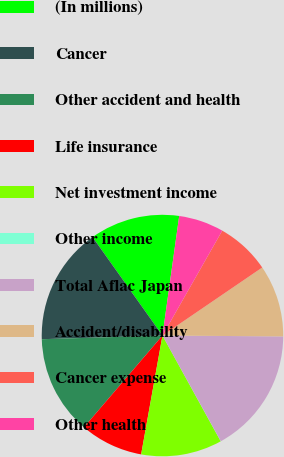Convert chart to OTSL. <chart><loc_0><loc_0><loc_500><loc_500><pie_chart><fcel>(In millions)<fcel>Cancer<fcel>Other accident and health<fcel>Life insurance<fcel>Net investment income<fcel>Other income<fcel>Total Aflac Japan<fcel>Accident/disability<fcel>Cancer expense<fcel>Other health<nl><fcel>12.04%<fcel>15.65%<fcel>13.25%<fcel>8.44%<fcel>10.84%<fcel>0.02%<fcel>16.85%<fcel>9.64%<fcel>7.23%<fcel>6.03%<nl></chart> 